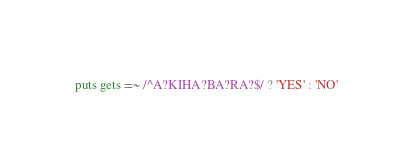<code> <loc_0><loc_0><loc_500><loc_500><_Ruby_>puts gets =~ /^A?KIHA?BA?RA?$/ ? 'YES' : 'NO'</code> 